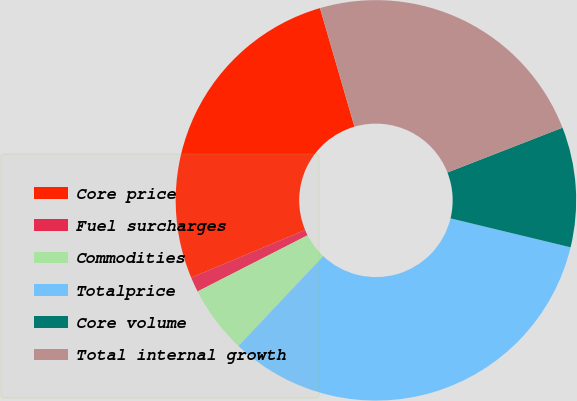Convert chart to OTSL. <chart><loc_0><loc_0><loc_500><loc_500><pie_chart><fcel>Core price<fcel>Fuel surcharges<fcel>Commodities<fcel>Totalprice<fcel>Core volume<fcel>Total internal growth<nl><fcel>26.8%<fcel>1.21%<fcel>5.44%<fcel>33.27%<fcel>9.68%<fcel>23.59%<nl></chart> 